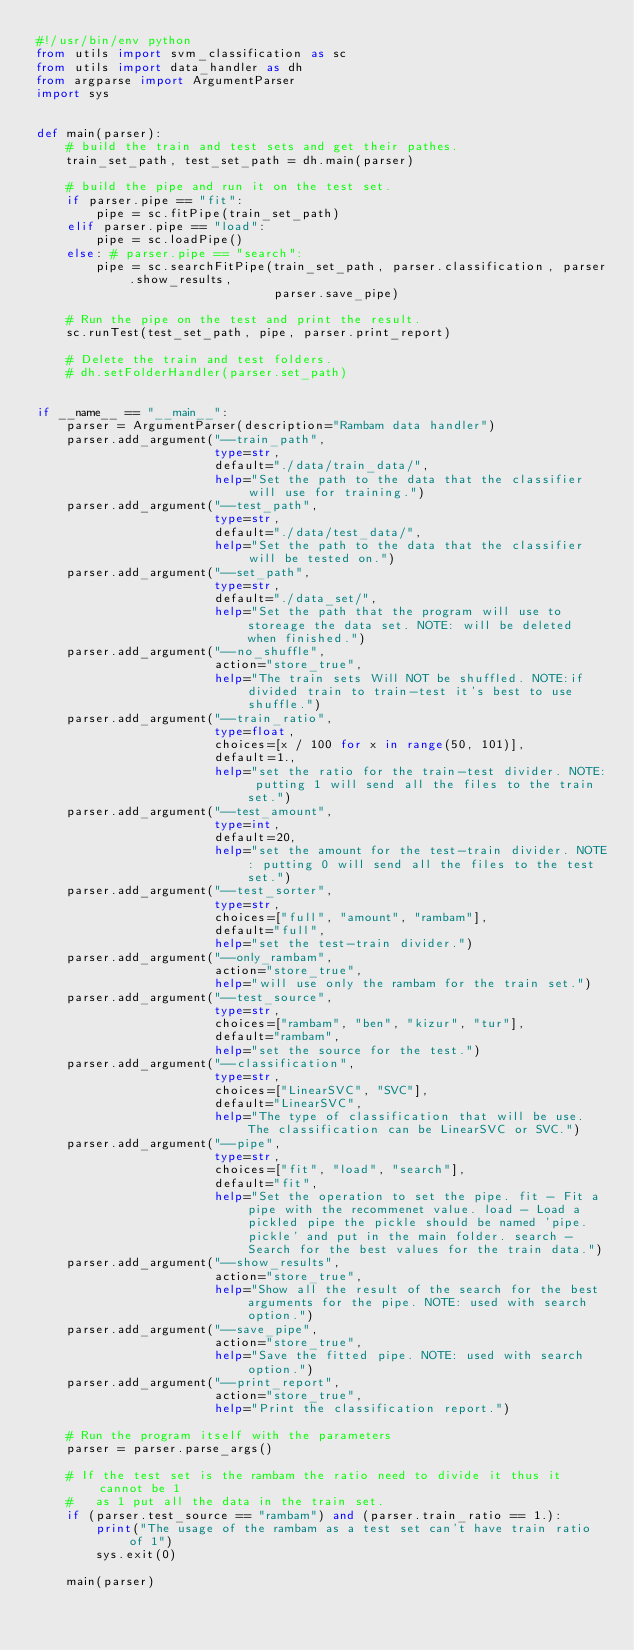Convert code to text. <code><loc_0><loc_0><loc_500><loc_500><_Python_>#!/usr/bin/env python
from utils import svm_classification as sc
from utils import data_handler as dh
from argparse import ArgumentParser
import sys


def main(parser):
    # build the train and test sets and get their pathes.
    train_set_path, test_set_path = dh.main(parser)

    # build the pipe and run it on the test set.
    if parser.pipe == "fit":
        pipe = sc.fitPipe(train_set_path)
    elif parser.pipe == "load":
        pipe = sc.loadPipe()
    else: # parser.pipe == "search":
        pipe = sc.searchFitPipe(train_set_path, parser.classification, parser.show_results,
                                parser.save_pipe)

    # Run the pipe on the test and print the result.
    sc.runTest(test_set_path, pipe, parser.print_report)

    # Delete the train and test folders.
    # dh.setFolderHandler(parser.set_path)


if __name__ == "__main__":
    parser = ArgumentParser(description="Rambam data handler")
    parser.add_argument("--train_path",
                        type=str,
                        default="./data/train_data/",
                        help="Set the path to the data that the classifier will use for training.")
    parser.add_argument("--test_path",
                        type=str,
                        default="./data/test_data/",
                        help="Set the path to the data that the classifier will be tested on.")
    parser.add_argument("--set_path",
                        type=str,
                        default="./data_set/",
                        help="Set the path that the program will use to storeage the data set. NOTE: will be deleted when finished.")
    parser.add_argument("--no_shuffle",
                        action="store_true",
                        help="The train sets Will NOT be shuffled. NOTE:if divided train to train-test it's best to use shuffle.")
    parser.add_argument("--train_ratio",
                        type=float,
                        choices=[x / 100 for x in range(50, 101)],
                        default=1.,
                        help="set the ratio for the train-test divider. NOTE: putting 1 will send all the files to the train set.")
    parser.add_argument("--test_amount",
                        type=int,
                        default=20,
                        help="set the amount for the test-train divider. NOTE: putting 0 will send all the files to the test set.")
    parser.add_argument("--test_sorter",
                        type=str,
                        choices=["full", "amount", "rambam"],
                        default="full",
                        help="set the test-train divider.")
    parser.add_argument("--only_rambam",
                        action="store_true",
                        help="will use only the rambam for the train set.")
    parser.add_argument("--test_source",
                        type=str,
                        choices=["rambam", "ben", "kizur", "tur"],
                        default="rambam",
                        help="set the source for the test.")
    parser.add_argument("--classification",
                        type=str,
                        choices=["LinearSVC", "SVC"],
                        default="LinearSVC",
                        help="The type of classification that will be use. The classification can be LinearSVC or SVC.")
    parser.add_argument("--pipe",
                        type=str,
                        choices=["fit", "load", "search"],
                        default="fit",
                        help="Set the operation to set the pipe. fit - Fit a pipe with the recommenet value. load - Load a pickled pipe the pickle should be named 'pipe.pickle' and put in the main folder. search - Search for the best values for the train data.")
    parser.add_argument("--show_results",
                        action="store_true",
                        help="Show all the result of the search for the best arguments for the pipe. NOTE: used with search option.")
    parser.add_argument("--save_pipe",
                        action="store_true",
                        help="Save the fitted pipe. NOTE: used with search option.")
    parser.add_argument("--print_report",
                        action="store_true",
                        help="Print the classification report.")

    # Run the program itself with the parameters
    parser = parser.parse_args()

    # If the test set is the rambam the ratio need to divide it thus it cannot be 1
    #   as 1 put all the data in the train set.
    if (parser.test_source == "rambam") and (parser.train_ratio == 1.):
        print("The usage of the rambam as a test set can't have train ratio of 1")
        sys.exit(0)

    main(parser)
</code> 